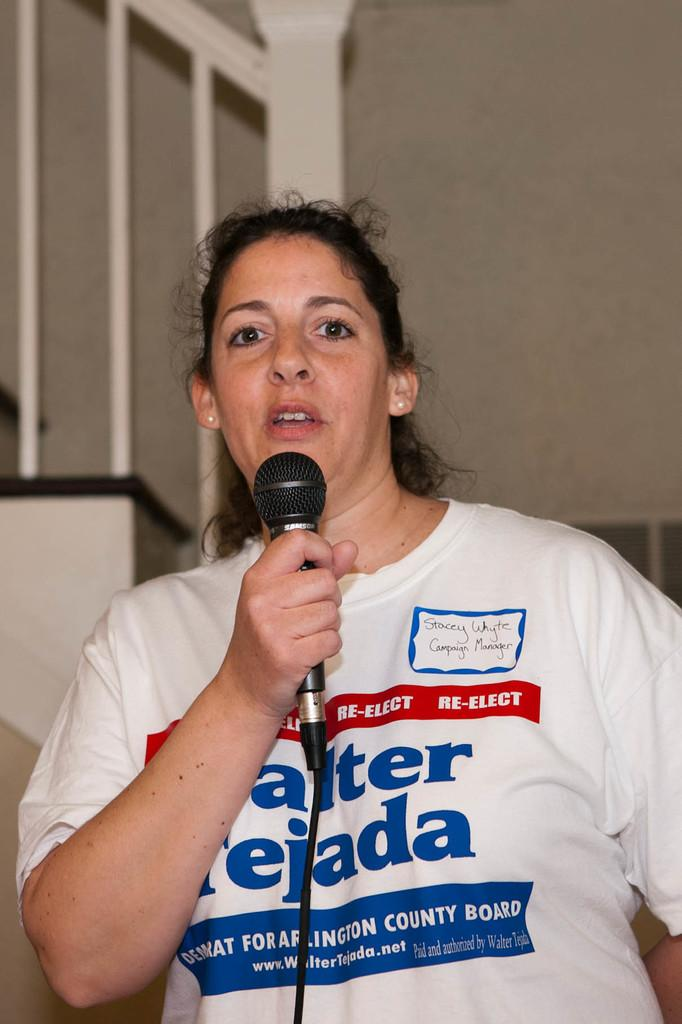What is the woman in the image doing? The woman is holding a microphone and watching and talking. What object is the woman holding in the image? The woman is holding a microphone. What can be seen in the background of the image? There is a wall, stairs, and a railing in the background of the image. What type of fish can be seen swimming in the background of the image? There are no fish present in the image; the background features a wall, stairs, and a railing. 